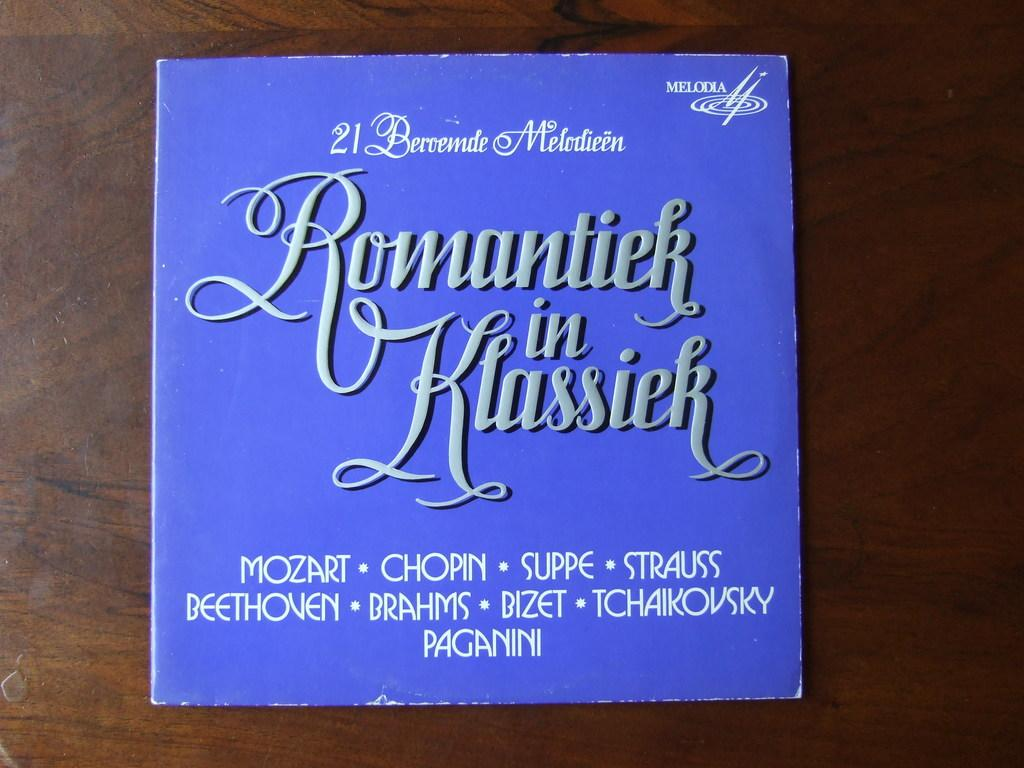<image>
Render a clear and concise summary of the photo. Blue album named Romantiek in Klassick placed on a wooden table. 